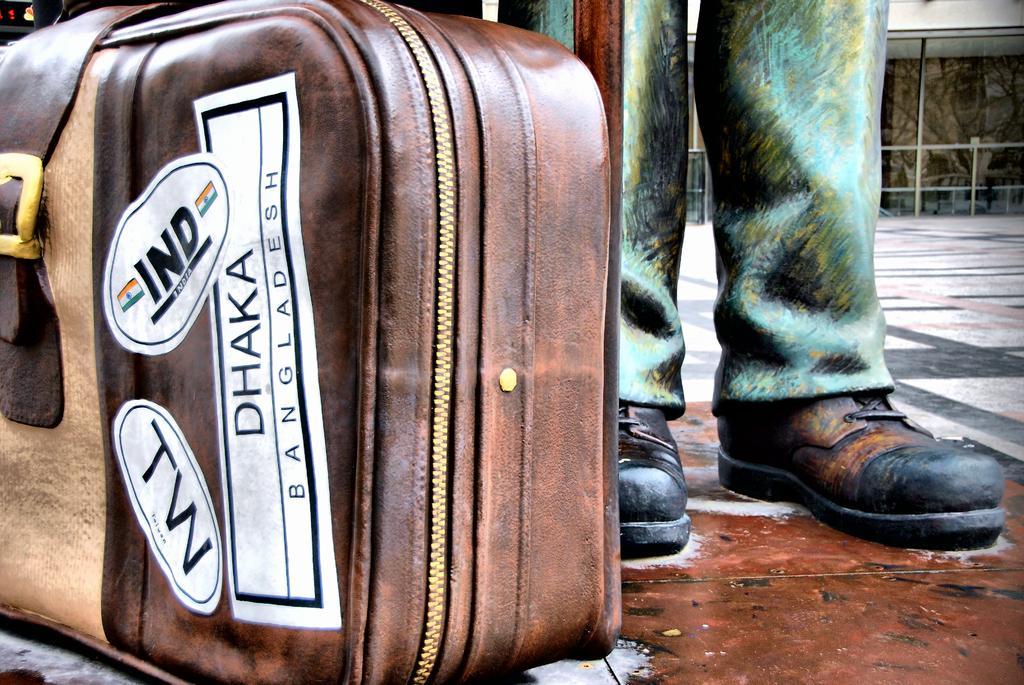How would you summarize this image in a sentence or two? Left side of the image there is a suitcase. Top right side of the image there is a person, Behind him there is a fencing. 